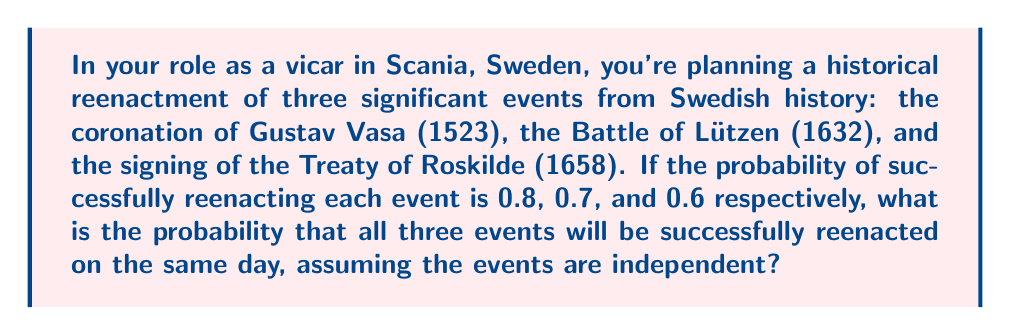Solve this math problem. To solve this problem, we need to apply the multiplication rule of probability for independent events. Since the events are independent, the probability of all three occurring simultaneously is the product of their individual probabilities.

Let's define our events:
$A$ = Successful reenactment of Gustav Vasa's coronation
$B$ = Successful reenactment of the Battle of Lützen
$C$ = Successful reenactment of the signing of the Treaty of Roskilde

Given probabilities:
$P(A) = 0.8$
$P(B) = 0.7$
$P(C) = 0.6$

The probability of all three events occurring simultaneously is:

$$P(A \cap B \cap C) = P(A) \times P(B) \times P(C)$$

Substituting the given probabilities:

$$P(A \cap B \cap C) = 0.8 \times 0.7 \times 0.6$$

Calculating:

$$P(A \cap B \cap C) = 0.336$$

Therefore, the probability that all three historical events will be successfully reenacted on the same day is 0.336 or 33.6%.
Answer: $0.336$ or $33.6\%$ 